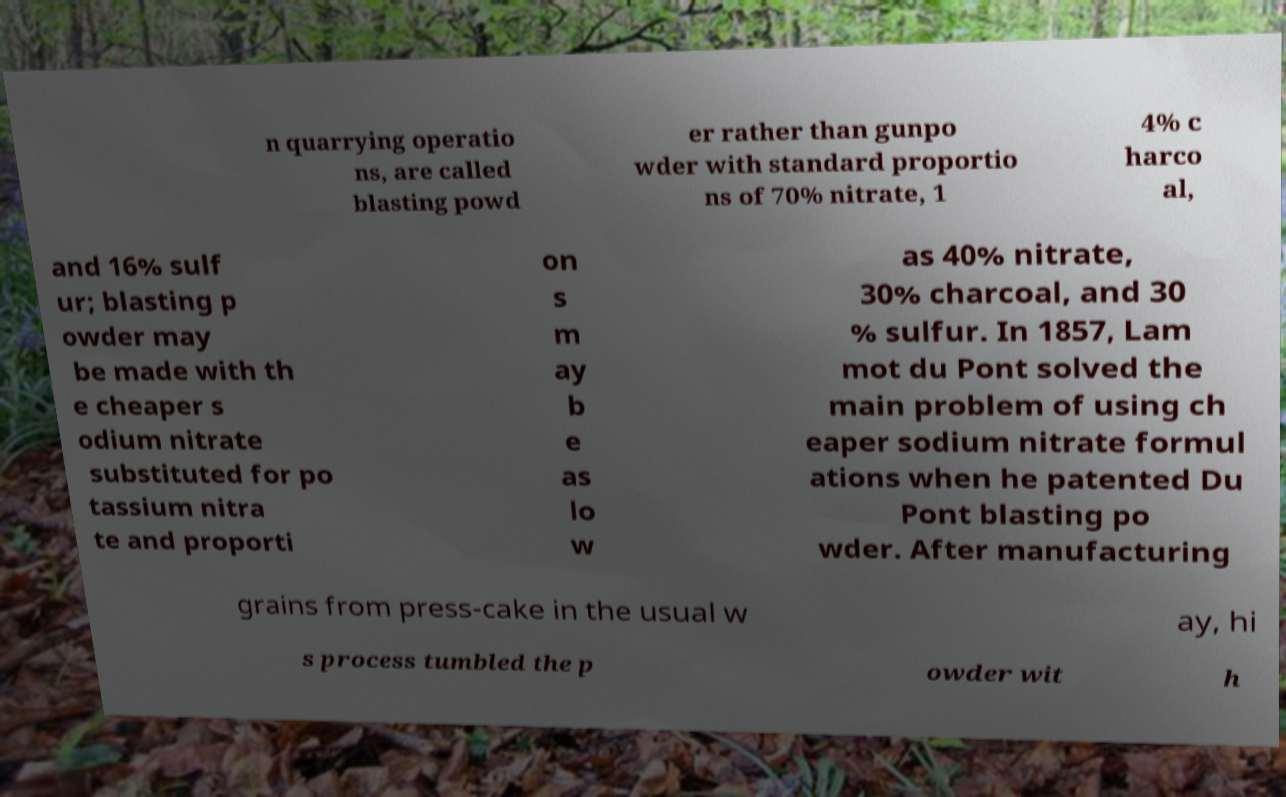Could you extract and type out the text from this image? n quarrying operatio ns, are called blasting powd er rather than gunpo wder with standard proportio ns of 70% nitrate, 1 4% c harco al, and 16% sulf ur; blasting p owder may be made with th e cheaper s odium nitrate substituted for po tassium nitra te and proporti on s m ay b e as lo w as 40% nitrate, 30% charcoal, and 30 % sulfur. In 1857, Lam mot du Pont solved the main problem of using ch eaper sodium nitrate formul ations when he patented Du Pont blasting po wder. After manufacturing grains from press-cake in the usual w ay, hi s process tumbled the p owder wit h 